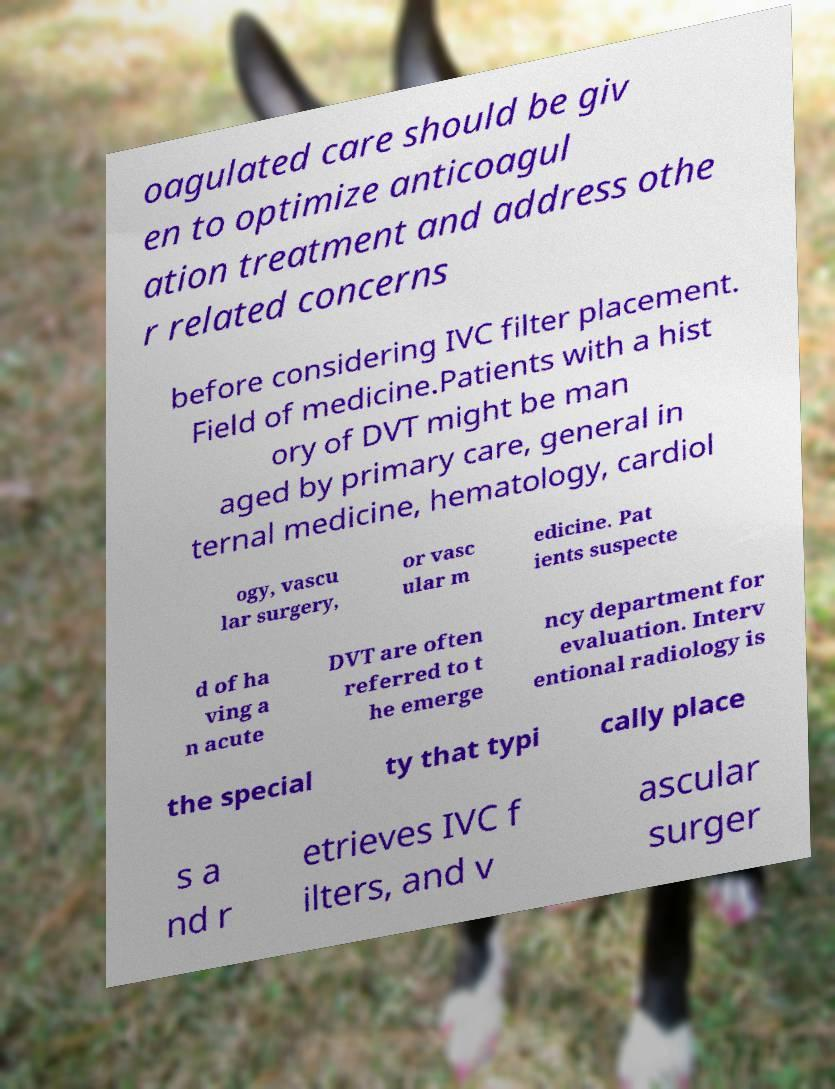For documentation purposes, I need the text within this image transcribed. Could you provide that? oagulated care should be giv en to optimize anticoagul ation treatment and address othe r related concerns before considering IVC filter placement. Field of medicine.Patients with a hist ory of DVT might be man aged by primary care, general in ternal medicine, hematology, cardiol ogy, vascu lar surgery, or vasc ular m edicine. Pat ients suspecte d of ha ving a n acute DVT are often referred to t he emerge ncy department for evaluation. Interv entional radiology is the special ty that typi cally place s a nd r etrieves IVC f ilters, and v ascular surger 